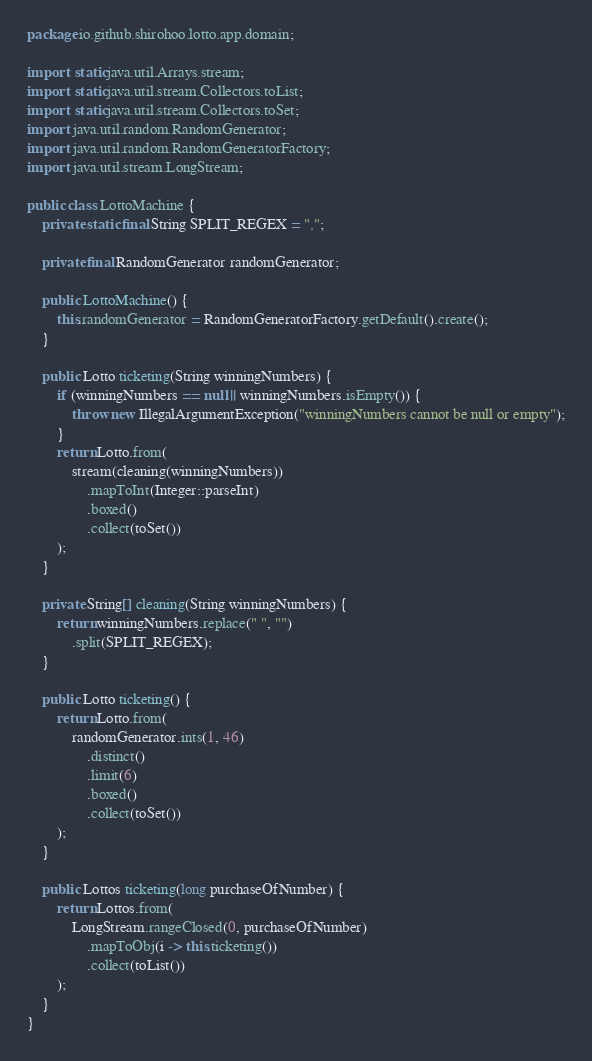<code> <loc_0><loc_0><loc_500><loc_500><_Java_>package io.github.shirohoo.lotto.app.domain;

import static java.util.Arrays.stream;
import static java.util.stream.Collectors.toList;
import static java.util.stream.Collectors.toSet;
import java.util.random.RandomGenerator;
import java.util.random.RandomGeneratorFactory;
import java.util.stream.LongStream;

public class LottoMachine {
    private static final String SPLIT_REGEX = ",";

    private final RandomGenerator randomGenerator;

    public LottoMachine() {
        this.randomGenerator = RandomGeneratorFactory.getDefault().create();
    }

    public Lotto ticketing(String winningNumbers) {
        if (winningNumbers == null || winningNumbers.isEmpty()) {
            throw new IllegalArgumentException("winningNumbers cannot be null or empty");
        }
        return Lotto.from(
            stream(cleaning(winningNumbers))
                .mapToInt(Integer::parseInt)
                .boxed()
                .collect(toSet())
        );
    }

    private String[] cleaning(String winningNumbers) {
        return winningNumbers.replace(" ", "")
            .split(SPLIT_REGEX);
    }

    public Lotto ticketing() {
        return Lotto.from(
            randomGenerator.ints(1, 46)
                .distinct()
                .limit(6)
                .boxed()
                .collect(toSet())
        );
    }

    public Lottos ticketing(long purchaseOfNumber) {
        return Lottos.from(
            LongStream.rangeClosed(0, purchaseOfNumber)
                .mapToObj(i -> this.ticketing())
                .collect(toList())
        );
    }
}
</code> 